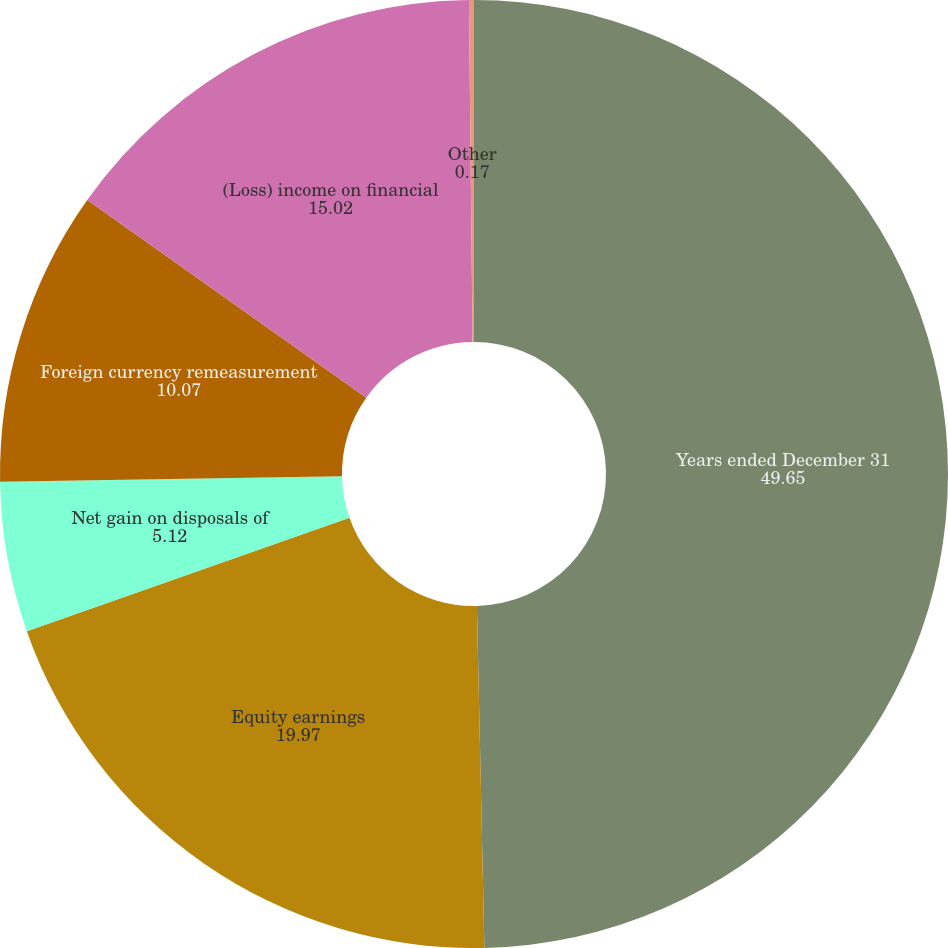Convert chart. <chart><loc_0><loc_0><loc_500><loc_500><pie_chart><fcel>Years ended December 31<fcel>Equity earnings<fcel>Net gain on disposals of<fcel>Foreign currency remeasurement<fcel>(Loss) income on financial<fcel>Other<nl><fcel>49.65%<fcel>19.97%<fcel>5.12%<fcel>10.07%<fcel>15.02%<fcel>0.17%<nl></chart> 